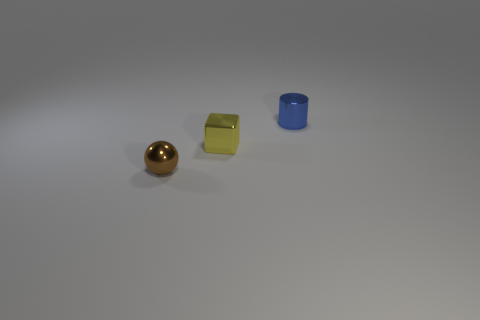Add 1 yellow shiny objects. How many objects exist? 4 Subtract 0 purple blocks. How many objects are left? 3 Subtract all balls. How many objects are left? 2 Subtract all yellow balls. Subtract all yellow blocks. How many balls are left? 1 Subtract all red cylinders. How many blue spheres are left? 0 Subtract all brown rubber blocks. Subtract all shiny blocks. How many objects are left? 2 Add 2 yellow shiny things. How many yellow shiny things are left? 3 Add 2 shiny things. How many shiny things exist? 5 